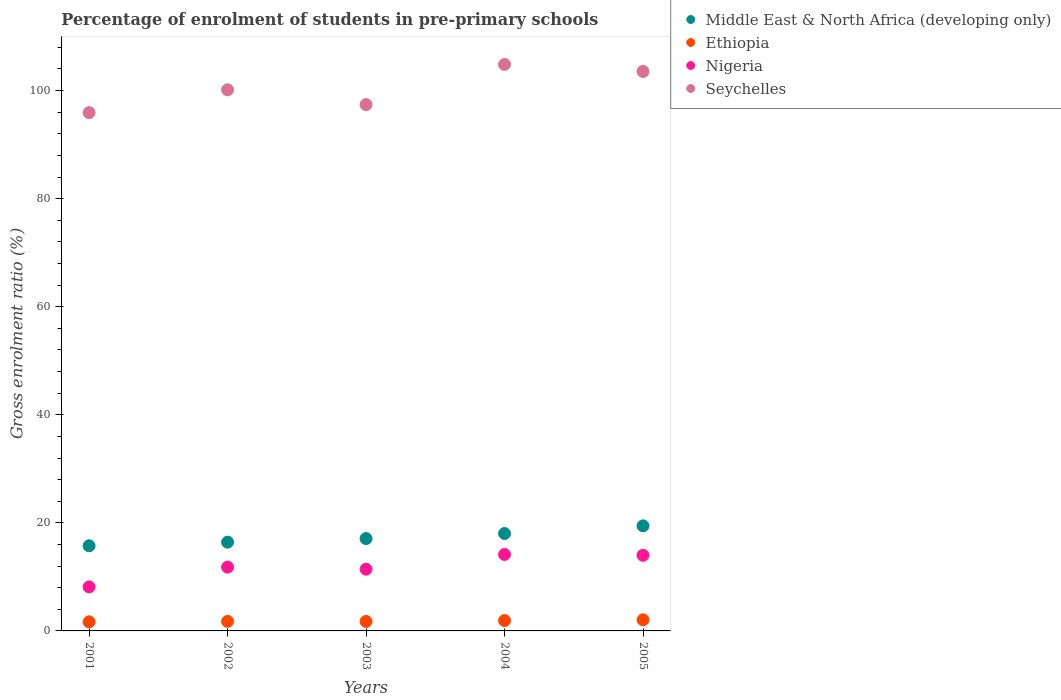How many different coloured dotlines are there?
Your answer should be very brief. 4. What is the percentage of students enrolled in pre-primary schools in Nigeria in 2004?
Offer a terse response. 14.15. Across all years, what is the maximum percentage of students enrolled in pre-primary schools in Seychelles?
Your answer should be compact. 104.84. Across all years, what is the minimum percentage of students enrolled in pre-primary schools in Nigeria?
Offer a very short reply. 8.15. In which year was the percentage of students enrolled in pre-primary schools in Seychelles minimum?
Keep it short and to the point. 2001. What is the total percentage of students enrolled in pre-primary schools in Middle East & North Africa (developing only) in the graph?
Your answer should be compact. 86.75. What is the difference between the percentage of students enrolled in pre-primary schools in Ethiopia in 2002 and that in 2003?
Give a very brief answer. 0.01. What is the difference between the percentage of students enrolled in pre-primary schools in Nigeria in 2002 and the percentage of students enrolled in pre-primary schools in Ethiopia in 2005?
Provide a short and direct response. 9.76. What is the average percentage of students enrolled in pre-primary schools in Middle East & North Africa (developing only) per year?
Provide a short and direct response. 17.35. In the year 2001, what is the difference between the percentage of students enrolled in pre-primary schools in Nigeria and percentage of students enrolled in pre-primary schools in Ethiopia?
Your answer should be compact. 6.47. In how many years, is the percentage of students enrolled in pre-primary schools in Nigeria greater than 40 %?
Give a very brief answer. 0. What is the ratio of the percentage of students enrolled in pre-primary schools in Seychelles in 2002 to that in 2004?
Make the answer very short. 0.96. Is the percentage of students enrolled in pre-primary schools in Ethiopia in 2003 less than that in 2004?
Provide a succinct answer. Yes. Is the difference between the percentage of students enrolled in pre-primary schools in Nigeria in 2002 and 2004 greater than the difference between the percentage of students enrolled in pre-primary schools in Ethiopia in 2002 and 2004?
Provide a short and direct response. No. What is the difference between the highest and the second highest percentage of students enrolled in pre-primary schools in Ethiopia?
Offer a very short reply. 0.14. What is the difference between the highest and the lowest percentage of students enrolled in pre-primary schools in Middle East & North Africa (developing only)?
Offer a terse response. 3.69. Is it the case that in every year, the sum of the percentage of students enrolled in pre-primary schools in Ethiopia and percentage of students enrolled in pre-primary schools in Nigeria  is greater than the percentage of students enrolled in pre-primary schools in Seychelles?
Ensure brevity in your answer.  No. Does the percentage of students enrolled in pre-primary schools in Ethiopia monotonically increase over the years?
Offer a very short reply. No. How many dotlines are there?
Provide a succinct answer. 4. Does the graph contain grids?
Your response must be concise. No. Where does the legend appear in the graph?
Keep it short and to the point. Top right. How are the legend labels stacked?
Keep it short and to the point. Vertical. What is the title of the graph?
Your response must be concise. Percentage of enrolment of students in pre-primary schools. What is the label or title of the Y-axis?
Your answer should be very brief. Gross enrolment ratio (%). What is the Gross enrolment ratio (%) of Middle East & North Africa (developing only) in 2001?
Your answer should be compact. 15.76. What is the Gross enrolment ratio (%) of Ethiopia in 2001?
Your answer should be compact. 1.68. What is the Gross enrolment ratio (%) of Nigeria in 2001?
Your response must be concise. 8.15. What is the Gross enrolment ratio (%) of Seychelles in 2001?
Your answer should be compact. 95.92. What is the Gross enrolment ratio (%) of Middle East & North Africa (developing only) in 2002?
Make the answer very short. 16.43. What is the Gross enrolment ratio (%) in Ethiopia in 2002?
Your answer should be compact. 1.76. What is the Gross enrolment ratio (%) in Nigeria in 2002?
Provide a succinct answer. 11.81. What is the Gross enrolment ratio (%) of Seychelles in 2002?
Make the answer very short. 100.14. What is the Gross enrolment ratio (%) of Middle East & North Africa (developing only) in 2003?
Your answer should be compact. 17.09. What is the Gross enrolment ratio (%) in Ethiopia in 2003?
Provide a succinct answer. 1.76. What is the Gross enrolment ratio (%) of Nigeria in 2003?
Provide a short and direct response. 11.42. What is the Gross enrolment ratio (%) in Seychelles in 2003?
Your answer should be compact. 97.4. What is the Gross enrolment ratio (%) in Middle East & North Africa (developing only) in 2004?
Keep it short and to the point. 18.03. What is the Gross enrolment ratio (%) in Ethiopia in 2004?
Keep it short and to the point. 1.92. What is the Gross enrolment ratio (%) in Nigeria in 2004?
Provide a short and direct response. 14.15. What is the Gross enrolment ratio (%) of Seychelles in 2004?
Provide a succinct answer. 104.84. What is the Gross enrolment ratio (%) of Middle East & North Africa (developing only) in 2005?
Give a very brief answer. 19.45. What is the Gross enrolment ratio (%) in Ethiopia in 2005?
Make the answer very short. 2.06. What is the Gross enrolment ratio (%) of Nigeria in 2005?
Give a very brief answer. 13.99. What is the Gross enrolment ratio (%) of Seychelles in 2005?
Give a very brief answer. 103.54. Across all years, what is the maximum Gross enrolment ratio (%) of Middle East & North Africa (developing only)?
Your answer should be compact. 19.45. Across all years, what is the maximum Gross enrolment ratio (%) of Ethiopia?
Keep it short and to the point. 2.06. Across all years, what is the maximum Gross enrolment ratio (%) in Nigeria?
Offer a terse response. 14.15. Across all years, what is the maximum Gross enrolment ratio (%) in Seychelles?
Give a very brief answer. 104.84. Across all years, what is the minimum Gross enrolment ratio (%) of Middle East & North Africa (developing only)?
Give a very brief answer. 15.76. Across all years, what is the minimum Gross enrolment ratio (%) of Ethiopia?
Keep it short and to the point. 1.68. Across all years, what is the minimum Gross enrolment ratio (%) of Nigeria?
Offer a terse response. 8.15. Across all years, what is the minimum Gross enrolment ratio (%) in Seychelles?
Give a very brief answer. 95.92. What is the total Gross enrolment ratio (%) in Middle East & North Africa (developing only) in the graph?
Provide a succinct answer. 86.75. What is the total Gross enrolment ratio (%) of Ethiopia in the graph?
Give a very brief answer. 9.18. What is the total Gross enrolment ratio (%) of Nigeria in the graph?
Keep it short and to the point. 59.53. What is the total Gross enrolment ratio (%) in Seychelles in the graph?
Offer a terse response. 501.85. What is the difference between the Gross enrolment ratio (%) of Middle East & North Africa (developing only) in 2001 and that in 2002?
Provide a succinct answer. -0.67. What is the difference between the Gross enrolment ratio (%) of Ethiopia in 2001 and that in 2002?
Provide a short and direct response. -0.08. What is the difference between the Gross enrolment ratio (%) in Nigeria in 2001 and that in 2002?
Keep it short and to the point. -3.66. What is the difference between the Gross enrolment ratio (%) in Seychelles in 2001 and that in 2002?
Your answer should be compact. -4.22. What is the difference between the Gross enrolment ratio (%) in Middle East & North Africa (developing only) in 2001 and that in 2003?
Offer a very short reply. -1.33. What is the difference between the Gross enrolment ratio (%) of Ethiopia in 2001 and that in 2003?
Keep it short and to the point. -0.07. What is the difference between the Gross enrolment ratio (%) in Nigeria in 2001 and that in 2003?
Offer a very short reply. -3.28. What is the difference between the Gross enrolment ratio (%) in Seychelles in 2001 and that in 2003?
Make the answer very short. -1.48. What is the difference between the Gross enrolment ratio (%) in Middle East & North Africa (developing only) in 2001 and that in 2004?
Your response must be concise. -2.27. What is the difference between the Gross enrolment ratio (%) in Ethiopia in 2001 and that in 2004?
Your response must be concise. -0.23. What is the difference between the Gross enrolment ratio (%) of Nigeria in 2001 and that in 2004?
Provide a succinct answer. -6.01. What is the difference between the Gross enrolment ratio (%) in Seychelles in 2001 and that in 2004?
Ensure brevity in your answer.  -8.92. What is the difference between the Gross enrolment ratio (%) of Middle East & North Africa (developing only) in 2001 and that in 2005?
Give a very brief answer. -3.69. What is the difference between the Gross enrolment ratio (%) of Ethiopia in 2001 and that in 2005?
Your answer should be compact. -0.37. What is the difference between the Gross enrolment ratio (%) of Nigeria in 2001 and that in 2005?
Give a very brief answer. -5.85. What is the difference between the Gross enrolment ratio (%) in Seychelles in 2001 and that in 2005?
Offer a terse response. -7.62. What is the difference between the Gross enrolment ratio (%) in Middle East & North Africa (developing only) in 2002 and that in 2003?
Your response must be concise. -0.66. What is the difference between the Gross enrolment ratio (%) of Ethiopia in 2002 and that in 2003?
Your answer should be compact. 0.01. What is the difference between the Gross enrolment ratio (%) in Nigeria in 2002 and that in 2003?
Keep it short and to the point. 0.39. What is the difference between the Gross enrolment ratio (%) of Seychelles in 2002 and that in 2003?
Provide a short and direct response. 2.74. What is the difference between the Gross enrolment ratio (%) in Middle East & North Africa (developing only) in 2002 and that in 2004?
Keep it short and to the point. -1.6. What is the difference between the Gross enrolment ratio (%) in Ethiopia in 2002 and that in 2004?
Your answer should be very brief. -0.15. What is the difference between the Gross enrolment ratio (%) in Nigeria in 2002 and that in 2004?
Give a very brief answer. -2.34. What is the difference between the Gross enrolment ratio (%) of Seychelles in 2002 and that in 2004?
Keep it short and to the point. -4.7. What is the difference between the Gross enrolment ratio (%) in Middle East & North Africa (developing only) in 2002 and that in 2005?
Your response must be concise. -3.02. What is the difference between the Gross enrolment ratio (%) of Ethiopia in 2002 and that in 2005?
Your response must be concise. -0.29. What is the difference between the Gross enrolment ratio (%) of Nigeria in 2002 and that in 2005?
Offer a very short reply. -2.18. What is the difference between the Gross enrolment ratio (%) of Seychelles in 2002 and that in 2005?
Offer a very short reply. -3.4. What is the difference between the Gross enrolment ratio (%) of Middle East & North Africa (developing only) in 2003 and that in 2004?
Give a very brief answer. -0.94. What is the difference between the Gross enrolment ratio (%) in Ethiopia in 2003 and that in 2004?
Provide a short and direct response. -0.16. What is the difference between the Gross enrolment ratio (%) of Nigeria in 2003 and that in 2004?
Offer a terse response. -2.73. What is the difference between the Gross enrolment ratio (%) in Seychelles in 2003 and that in 2004?
Make the answer very short. -7.44. What is the difference between the Gross enrolment ratio (%) of Middle East & North Africa (developing only) in 2003 and that in 2005?
Provide a succinct answer. -2.36. What is the difference between the Gross enrolment ratio (%) of Ethiopia in 2003 and that in 2005?
Offer a very short reply. -0.3. What is the difference between the Gross enrolment ratio (%) of Nigeria in 2003 and that in 2005?
Give a very brief answer. -2.57. What is the difference between the Gross enrolment ratio (%) of Seychelles in 2003 and that in 2005?
Ensure brevity in your answer.  -6.14. What is the difference between the Gross enrolment ratio (%) in Middle East & North Africa (developing only) in 2004 and that in 2005?
Keep it short and to the point. -1.42. What is the difference between the Gross enrolment ratio (%) of Ethiopia in 2004 and that in 2005?
Ensure brevity in your answer.  -0.14. What is the difference between the Gross enrolment ratio (%) in Nigeria in 2004 and that in 2005?
Ensure brevity in your answer.  0.16. What is the difference between the Gross enrolment ratio (%) in Seychelles in 2004 and that in 2005?
Offer a terse response. 1.3. What is the difference between the Gross enrolment ratio (%) in Middle East & North Africa (developing only) in 2001 and the Gross enrolment ratio (%) in Ethiopia in 2002?
Make the answer very short. 13.99. What is the difference between the Gross enrolment ratio (%) in Middle East & North Africa (developing only) in 2001 and the Gross enrolment ratio (%) in Nigeria in 2002?
Offer a very short reply. 3.95. What is the difference between the Gross enrolment ratio (%) of Middle East & North Africa (developing only) in 2001 and the Gross enrolment ratio (%) of Seychelles in 2002?
Offer a terse response. -84.38. What is the difference between the Gross enrolment ratio (%) of Ethiopia in 2001 and the Gross enrolment ratio (%) of Nigeria in 2002?
Make the answer very short. -10.13. What is the difference between the Gross enrolment ratio (%) of Ethiopia in 2001 and the Gross enrolment ratio (%) of Seychelles in 2002?
Ensure brevity in your answer.  -98.46. What is the difference between the Gross enrolment ratio (%) of Nigeria in 2001 and the Gross enrolment ratio (%) of Seychelles in 2002?
Your answer should be very brief. -92. What is the difference between the Gross enrolment ratio (%) in Middle East & North Africa (developing only) in 2001 and the Gross enrolment ratio (%) in Ethiopia in 2003?
Ensure brevity in your answer.  14. What is the difference between the Gross enrolment ratio (%) of Middle East & North Africa (developing only) in 2001 and the Gross enrolment ratio (%) of Nigeria in 2003?
Keep it short and to the point. 4.33. What is the difference between the Gross enrolment ratio (%) of Middle East & North Africa (developing only) in 2001 and the Gross enrolment ratio (%) of Seychelles in 2003?
Offer a terse response. -81.64. What is the difference between the Gross enrolment ratio (%) in Ethiopia in 2001 and the Gross enrolment ratio (%) in Nigeria in 2003?
Your answer should be very brief. -9.74. What is the difference between the Gross enrolment ratio (%) in Ethiopia in 2001 and the Gross enrolment ratio (%) in Seychelles in 2003?
Keep it short and to the point. -95.72. What is the difference between the Gross enrolment ratio (%) in Nigeria in 2001 and the Gross enrolment ratio (%) in Seychelles in 2003?
Give a very brief answer. -89.26. What is the difference between the Gross enrolment ratio (%) in Middle East & North Africa (developing only) in 2001 and the Gross enrolment ratio (%) in Ethiopia in 2004?
Your answer should be compact. 13.84. What is the difference between the Gross enrolment ratio (%) in Middle East & North Africa (developing only) in 2001 and the Gross enrolment ratio (%) in Nigeria in 2004?
Your answer should be compact. 1.6. What is the difference between the Gross enrolment ratio (%) of Middle East & North Africa (developing only) in 2001 and the Gross enrolment ratio (%) of Seychelles in 2004?
Your response must be concise. -89.08. What is the difference between the Gross enrolment ratio (%) of Ethiopia in 2001 and the Gross enrolment ratio (%) of Nigeria in 2004?
Ensure brevity in your answer.  -12.47. What is the difference between the Gross enrolment ratio (%) in Ethiopia in 2001 and the Gross enrolment ratio (%) in Seychelles in 2004?
Your response must be concise. -103.16. What is the difference between the Gross enrolment ratio (%) in Nigeria in 2001 and the Gross enrolment ratio (%) in Seychelles in 2004?
Offer a very short reply. -96.69. What is the difference between the Gross enrolment ratio (%) of Middle East & North Africa (developing only) in 2001 and the Gross enrolment ratio (%) of Ethiopia in 2005?
Provide a succinct answer. 13.7. What is the difference between the Gross enrolment ratio (%) in Middle East & North Africa (developing only) in 2001 and the Gross enrolment ratio (%) in Nigeria in 2005?
Make the answer very short. 1.77. What is the difference between the Gross enrolment ratio (%) of Middle East & North Africa (developing only) in 2001 and the Gross enrolment ratio (%) of Seychelles in 2005?
Keep it short and to the point. -87.78. What is the difference between the Gross enrolment ratio (%) of Ethiopia in 2001 and the Gross enrolment ratio (%) of Nigeria in 2005?
Your answer should be very brief. -12.31. What is the difference between the Gross enrolment ratio (%) in Ethiopia in 2001 and the Gross enrolment ratio (%) in Seychelles in 2005?
Ensure brevity in your answer.  -101.86. What is the difference between the Gross enrolment ratio (%) in Nigeria in 2001 and the Gross enrolment ratio (%) in Seychelles in 2005?
Keep it short and to the point. -95.39. What is the difference between the Gross enrolment ratio (%) of Middle East & North Africa (developing only) in 2002 and the Gross enrolment ratio (%) of Ethiopia in 2003?
Offer a terse response. 14.67. What is the difference between the Gross enrolment ratio (%) of Middle East & North Africa (developing only) in 2002 and the Gross enrolment ratio (%) of Nigeria in 2003?
Offer a terse response. 5. What is the difference between the Gross enrolment ratio (%) of Middle East & North Africa (developing only) in 2002 and the Gross enrolment ratio (%) of Seychelles in 2003?
Offer a terse response. -80.97. What is the difference between the Gross enrolment ratio (%) of Ethiopia in 2002 and the Gross enrolment ratio (%) of Nigeria in 2003?
Provide a succinct answer. -9.66. What is the difference between the Gross enrolment ratio (%) in Ethiopia in 2002 and the Gross enrolment ratio (%) in Seychelles in 2003?
Your answer should be very brief. -95.64. What is the difference between the Gross enrolment ratio (%) in Nigeria in 2002 and the Gross enrolment ratio (%) in Seychelles in 2003?
Give a very brief answer. -85.59. What is the difference between the Gross enrolment ratio (%) of Middle East & North Africa (developing only) in 2002 and the Gross enrolment ratio (%) of Ethiopia in 2004?
Offer a very short reply. 14.51. What is the difference between the Gross enrolment ratio (%) in Middle East & North Africa (developing only) in 2002 and the Gross enrolment ratio (%) in Nigeria in 2004?
Offer a terse response. 2.27. What is the difference between the Gross enrolment ratio (%) in Middle East & North Africa (developing only) in 2002 and the Gross enrolment ratio (%) in Seychelles in 2004?
Offer a very short reply. -88.41. What is the difference between the Gross enrolment ratio (%) in Ethiopia in 2002 and the Gross enrolment ratio (%) in Nigeria in 2004?
Keep it short and to the point. -12.39. What is the difference between the Gross enrolment ratio (%) in Ethiopia in 2002 and the Gross enrolment ratio (%) in Seychelles in 2004?
Offer a terse response. -103.08. What is the difference between the Gross enrolment ratio (%) in Nigeria in 2002 and the Gross enrolment ratio (%) in Seychelles in 2004?
Offer a very short reply. -93.03. What is the difference between the Gross enrolment ratio (%) in Middle East & North Africa (developing only) in 2002 and the Gross enrolment ratio (%) in Ethiopia in 2005?
Make the answer very short. 14.37. What is the difference between the Gross enrolment ratio (%) in Middle East & North Africa (developing only) in 2002 and the Gross enrolment ratio (%) in Nigeria in 2005?
Offer a terse response. 2.44. What is the difference between the Gross enrolment ratio (%) of Middle East & North Africa (developing only) in 2002 and the Gross enrolment ratio (%) of Seychelles in 2005?
Ensure brevity in your answer.  -87.11. What is the difference between the Gross enrolment ratio (%) in Ethiopia in 2002 and the Gross enrolment ratio (%) in Nigeria in 2005?
Offer a very short reply. -12.23. What is the difference between the Gross enrolment ratio (%) in Ethiopia in 2002 and the Gross enrolment ratio (%) in Seychelles in 2005?
Ensure brevity in your answer.  -101.77. What is the difference between the Gross enrolment ratio (%) of Nigeria in 2002 and the Gross enrolment ratio (%) of Seychelles in 2005?
Your answer should be compact. -91.73. What is the difference between the Gross enrolment ratio (%) of Middle East & North Africa (developing only) in 2003 and the Gross enrolment ratio (%) of Ethiopia in 2004?
Your response must be concise. 15.17. What is the difference between the Gross enrolment ratio (%) in Middle East & North Africa (developing only) in 2003 and the Gross enrolment ratio (%) in Nigeria in 2004?
Keep it short and to the point. 2.94. What is the difference between the Gross enrolment ratio (%) in Middle East & North Africa (developing only) in 2003 and the Gross enrolment ratio (%) in Seychelles in 2004?
Offer a very short reply. -87.75. What is the difference between the Gross enrolment ratio (%) in Ethiopia in 2003 and the Gross enrolment ratio (%) in Nigeria in 2004?
Provide a succinct answer. -12.4. What is the difference between the Gross enrolment ratio (%) in Ethiopia in 2003 and the Gross enrolment ratio (%) in Seychelles in 2004?
Give a very brief answer. -103.08. What is the difference between the Gross enrolment ratio (%) of Nigeria in 2003 and the Gross enrolment ratio (%) of Seychelles in 2004?
Ensure brevity in your answer.  -93.42. What is the difference between the Gross enrolment ratio (%) in Middle East & North Africa (developing only) in 2003 and the Gross enrolment ratio (%) in Ethiopia in 2005?
Provide a succinct answer. 15.03. What is the difference between the Gross enrolment ratio (%) of Middle East & North Africa (developing only) in 2003 and the Gross enrolment ratio (%) of Nigeria in 2005?
Provide a succinct answer. 3.1. What is the difference between the Gross enrolment ratio (%) of Middle East & North Africa (developing only) in 2003 and the Gross enrolment ratio (%) of Seychelles in 2005?
Your answer should be very brief. -86.45. What is the difference between the Gross enrolment ratio (%) in Ethiopia in 2003 and the Gross enrolment ratio (%) in Nigeria in 2005?
Offer a terse response. -12.24. What is the difference between the Gross enrolment ratio (%) in Ethiopia in 2003 and the Gross enrolment ratio (%) in Seychelles in 2005?
Your response must be concise. -101.78. What is the difference between the Gross enrolment ratio (%) of Nigeria in 2003 and the Gross enrolment ratio (%) of Seychelles in 2005?
Keep it short and to the point. -92.12. What is the difference between the Gross enrolment ratio (%) in Middle East & North Africa (developing only) in 2004 and the Gross enrolment ratio (%) in Ethiopia in 2005?
Give a very brief answer. 15.97. What is the difference between the Gross enrolment ratio (%) in Middle East & North Africa (developing only) in 2004 and the Gross enrolment ratio (%) in Nigeria in 2005?
Keep it short and to the point. 4.04. What is the difference between the Gross enrolment ratio (%) in Middle East & North Africa (developing only) in 2004 and the Gross enrolment ratio (%) in Seychelles in 2005?
Give a very brief answer. -85.51. What is the difference between the Gross enrolment ratio (%) of Ethiopia in 2004 and the Gross enrolment ratio (%) of Nigeria in 2005?
Provide a succinct answer. -12.08. What is the difference between the Gross enrolment ratio (%) in Ethiopia in 2004 and the Gross enrolment ratio (%) in Seychelles in 2005?
Your answer should be very brief. -101.62. What is the difference between the Gross enrolment ratio (%) in Nigeria in 2004 and the Gross enrolment ratio (%) in Seychelles in 2005?
Provide a succinct answer. -89.39. What is the average Gross enrolment ratio (%) of Middle East & North Africa (developing only) per year?
Your answer should be compact. 17.35. What is the average Gross enrolment ratio (%) in Ethiopia per year?
Offer a very short reply. 1.84. What is the average Gross enrolment ratio (%) of Nigeria per year?
Ensure brevity in your answer.  11.91. What is the average Gross enrolment ratio (%) of Seychelles per year?
Make the answer very short. 100.37. In the year 2001, what is the difference between the Gross enrolment ratio (%) in Middle East & North Africa (developing only) and Gross enrolment ratio (%) in Ethiopia?
Ensure brevity in your answer.  14.08. In the year 2001, what is the difference between the Gross enrolment ratio (%) in Middle East & North Africa (developing only) and Gross enrolment ratio (%) in Nigeria?
Keep it short and to the point. 7.61. In the year 2001, what is the difference between the Gross enrolment ratio (%) in Middle East & North Africa (developing only) and Gross enrolment ratio (%) in Seychelles?
Your response must be concise. -80.16. In the year 2001, what is the difference between the Gross enrolment ratio (%) of Ethiopia and Gross enrolment ratio (%) of Nigeria?
Ensure brevity in your answer.  -6.46. In the year 2001, what is the difference between the Gross enrolment ratio (%) in Ethiopia and Gross enrolment ratio (%) in Seychelles?
Offer a terse response. -94.24. In the year 2001, what is the difference between the Gross enrolment ratio (%) in Nigeria and Gross enrolment ratio (%) in Seychelles?
Provide a short and direct response. -87.77. In the year 2002, what is the difference between the Gross enrolment ratio (%) in Middle East & North Africa (developing only) and Gross enrolment ratio (%) in Ethiopia?
Provide a succinct answer. 14.66. In the year 2002, what is the difference between the Gross enrolment ratio (%) in Middle East & North Africa (developing only) and Gross enrolment ratio (%) in Nigeria?
Your answer should be very brief. 4.62. In the year 2002, what is the difference between the Gross enrolment ratio (%) of Middle East & North Africa (developing only) and Gross enrolment ratio (%) of Seychelles?
Provide a succinct answer. -83.71. In the year 2002, what is the difference between the Gross enrolment ratio (%) in Ethiopia and Gross enrolment ratio (%) in Nigeria?
Offer a very short reply. -10.05. In the year 2002, what is the difference between the Gross enrolment ratio (%) in Ethiopia and Gross enrolment ratio (%) in Seychelles?
Provide a short and direct response. -98.38. In the year 2002, what is the difference between the Gross enrolment ratio (%) in Nigeria and Gross enrolment ratio (%) in Seychelles?
Offer a very short reply. -88.33. In the year 2003, what is the difference between the Gross enrolment ratio (%) of Middle East & North Africa (developing only) and Gross enrolment ratio (%) of Ethiopia?
Ensure brevity in your answer.  15.33. In the year 2003, what is the difference between the Gross enrolment ratio (%) of Middle East & North Africa (developing only) and Gross enrolment ratio (%) of Nigeria?
Provide a short and direct response. 5.67. In the year 2003, what is the difference between the Gross enrolment ratio (%) of Middle East & North Africa (developing only) and Gross enrolment ratio (%) of Seychelles?
Make the answer very short. -80.31. In the year 2003, what is the difference between the Gross enrolment ratio (%) of Ethiopia and Gross enrolment ratio (%) of Nigeria?
Make the answer very short. -9.67. In the year 2003, what is the difference between the Gross enrolment ratio (%) of Ethiopia and Gross enrolment ratio (%) of Seychelles?
Provide a short and direct response. -95.65. In the year 2003, what is the difference between the Gross enrolment ratio (%) in Nigeria and Gross enrolment ratio (%) in Seychelles?
Offer a very short reply. -85.98. In the year 2004, what is the difference between the Gross enrolment ratio (%) in Middle East & North Africa (developing only) and Gross enrolment ratio (%) in Ethiopia?
Your response must be concise. 16.11. In the year 2004, what is the difference between the Gross enrolment ratio (%) in Middle East & North Africa (developing only) and Gross enrolment ratio (%) in Nigeria?
Give a very brief answer. 3.87. In the year 2004, what is the difference between the Gross enrolment ratio (%) in Middle East & North Africa (developing only) and Gross enrolment ratio (%) in Seychelles?
Make the answer very short. -86.81. In the year 2004, what is the difference between the Gross enrolment ratio (%) of Ethiopia and Gross enrolment ratio (%) of Nigeria?
Offer a very short reply. -12.24. In the year 2004, what is the difference between the Gross enrolment ratio (%) in Ethiopia and Gross enrolment ratio (%) in Seychelles?
Provide a succinct answer. -102.92. In the year 2004, what is the difference between the Gross enrolment ratio (%) of Nigeria and Gross enrolment ratio (%) of Seychelles?
Your answer should be compact. -90.69. In the year 2005, what is the difference between the Gross enrolment ratio (%) of Middle East & North Africa (developing only) and Gross enrolment ratio (%) of Ethiopia?
Ensure brevity in your answer.  17.39. In the year 2005, what is the difference between the Gross enrolment ratio (%) of Middle East & North Africa (developing only) and Gross enrolment ratio (%) of Nigeria?
Provide a succinct answer. 5.45. In the year 2005, what is the difference between the Gross enrolment ratio (%) of Middle East & North Africa (developing only) and Gross enrolment ratio (%) of Seychelles?
Provide a short and direct response. -84.09. In the year 2005, what is the difference between the Gross enrolment ratio (%) in Ethiopia and Gross enrolment ratio (%) in Nigeria?
Provide a succinct answer. -11.94. In the year 2005, what is the difference between the Gross enrolment ratio (%) of Ethiopia and Gross enrolment ratio (%) of Seychelles?
Make the answer very short. -101.48. In the year 2005, what is the difference between the Gross enrolment ratio (%) of Nigeria and Gross enrolment ratio (%) of Seychelles?
Keep it short and to the point. -89.55. What is the ratio of the Gross enrolment ratio (%) in Middle East & North Africa (developing only) in 2001 to that in 2002?
Make the answer very short. 0.96. What is the ratio of the Gross enrolment ratio (%) of Ethiopia in 2001 to that in 2002?
Your response must be concise. 0.95. What is the ratio of the Gross enrolment ratio (%) in Nigeria in 2001 to that in 2002?
Your response must be concise. 0.69. What is the ratio of the Gross enrolment ratio (%) of Seychelles in 2001 to that in 2002?
Give a very brief answer. 0.96. What is the ratio of the Gross enrolment ratio (%) in Middle East & North Africa (developing only) in 2001 to that in 2003?
Provide a succinct answer. 0.92. What is the ratio of the Gross enrolment ratio (%) of Ethiopia in 2001 to that in 2003?
Provide a succinct answer. 0.96. What is the ratio of the Gross enrolment ratio (%) in Nigeria in 2001 to that in 2003?
Offer a terse response. 0.71. What is the ratio of the Gross enrolment ratio (%) of Middle East & North Africa (developing only) in 2001 to that in 2004?
Offer a terse response. 0.87. What is the ratio of the Gross enrolment ratio (%) in Ethiopia in 2001 to that in 2004?
Keep it short and to the point. 0.88. What is the ratio of the Gross enrolment ratio (%) of Nigeria in 2001 to that in 2004?
Provide a short and direct response. 0.58. What is the ratio of the Gross enrolment ratio (%) of Seychelles in 2001 to that in 2004?
Keep it short and to the point. 0.91. What is the ratio of the Gross enrolment ratio (%) of Middle East & North Africa (developing only) in 2001 to that in 2005?
Your answer should be compact. 0.81. What is the ratio of the Gross enrolment ratio (%) of Ethiopia in 2001 to that in 2005?
Your answer should be very brief. 0.82. What is the ratio of the Gross enrolment ratio (%) of Nigeria in 2001 to that in 2005?
Your answer should be very brief. 0.58. What is the ratio of the Gross enrolment ratio (%) of Seychelles in 2001 to that in 2005?
Make the answer very short. 0.93. What is the ratio of the Gross enrolment ratio (%) of Middle East & North Africa (developing only) in 2002 to that in 2003?
Provide a short and direct response. 0.96. What is the ratio of the Gross enrolment ratio (%) of Ethiopia in 2002 to that in 2003?
Ensure brevity in your answer.  1. What is the ratio of the Gross enrolment ratio (%) in Nigeria in 2002 to that in 2003?
Offer a terse response. 1.03. What is the ratio of the Gross enrolment ratio (%) in Seychelles in 2002 to that in 2003?
Your response must be concise. 1.03. What is the ratio of the Gross enrolment ratio (%) of Middle East & North Africa (developing only) in 2002 to that in 2004?
Offer a terse response. 0.91. What is the ratio of the Gross enrolment ratio (%) in Ethiopia in 2002 to that in 2004?
Your answer should be compact. 0.92. What is the ratio of the Gross enrolment ratio (%) of Nigeria in 2002 to that in 2004?
Keep it short and to the point. 0.83. What is the ratio of the Gross enrolment ratio (%) of Seychelles in 2002 to that in 2004?
Ensure brevity in your answer.  0.96. What is the ratio of the Gross enrolment ratio (%) of Middle East & North Africa (developing only) in 2002 to that in 2005?
Give a very brief answer. 0.84. What is the ratio of the Gross enrolment ratio (%) of Ethiopia in 2002 to that in 2005?
Your answer should be very brief. 0.86. What is the ratio of the Gross enrolment ratio (%) in Nigeria in 2002 to that in 2005?
Keep it short and to the point. 0.84. What is the ratio of the Gross enrolment ratio (%) in Seychelles in 2002 to that in 2005?
Make the answer very short. 0.97. What is the ratio of the Gross enrolment ratio (%) of Middle East & North Africa (developing only) in 2003 to that in 2004?
Offer a terse response. 0.95. What is the ratio of the Gross enrolment ratio (%) in Ethiopia in 2003 to that in 2004?
Ensure brevity in your answer.  0.92. What is the ratio of the Gross enrolment ratio (%) of Nigeria in 2003 to that in 2004?
Keep it short and to the point. 0.81. What is the ratio of the Gross enrolment ratio (%) of Seychelles in 2003 to that in 2004?
Ensure brevity in your answer.  0.93. What is the ratio of the Gross enrolment ratio (%) in Middle East & North Africa (developing only) in 2003 to that in 2005?
Offer a very short reply. 0.88. What is the ratio of the Gross enrolment ratio (%) in Ethiopia in 2003 to that in 2005?
Ensure brevity in your answer.  0.85. What is the ratio of the Gross enrolment ratio (%) of Nigeria in 2003 to that in 2005?
Make the answer very short. 0.82. What is the ratio of the Gross enrolment ratio (%) of Seychelles in 2003 to that in 2005?
Your answer should be very brief. 0.94. What is the ratio of the Gross enrolment ratio (%) in Middle East & North Africa (developing only) in 2004 to that in 2005?
Keep it short and to the point. 0.93. What is the ratio of the Gross enrolment ratio (%) of Ethiopia in 2004 to that in 2005?
Keep it short and to the point. 0.93. What is the ratio of the Gross enrolment ratio (%) in Nigeria in 2004 to that in 2005?
Provide a short and direct response. 1.01. What is the ratio of the Gross enrolment ratio (%) of Seychelles in 2004 to that in 2005?
Your answer should be very brief. 1.01. What is the difference between the highest and the second highest Gross enrolment ratio (%) of Middle East & North Africa (developing only)?
Provide a short and direct response. 1.42. What is the difference between the highest and the second highest Gross enrolment ratio (%) of Ethiopia?
Your answer should be compact. 0.14. What is the difference between the highest and the second highest Gross enrolment ratio (%) in Nigeria?
Make the answer very short. 0.16. What is the difference between the highest and the second highest Gross enrolment ratio (%) in Seychelles?
Give a very brief answer. 1.3. What is the difference between the highest and the lowest Gross enrolment ratio (%) in Middle East & North Africa (developing only)?
Give a very brief answer. 3.69. What is the difference between the highest and the lowest Gross enrolment ratio (%) in Ethiopia?
Your response must be concise. 0.37. What is the difference between the highest and the lowest Gross enrolment ratio (%) of Nigeria?
Provide a short and direct response. 6.01. What is the difference between the highest and the lowest Gross enrolment ratio (%) of Seychelles?
Provide a succinct answer. 8.92. 